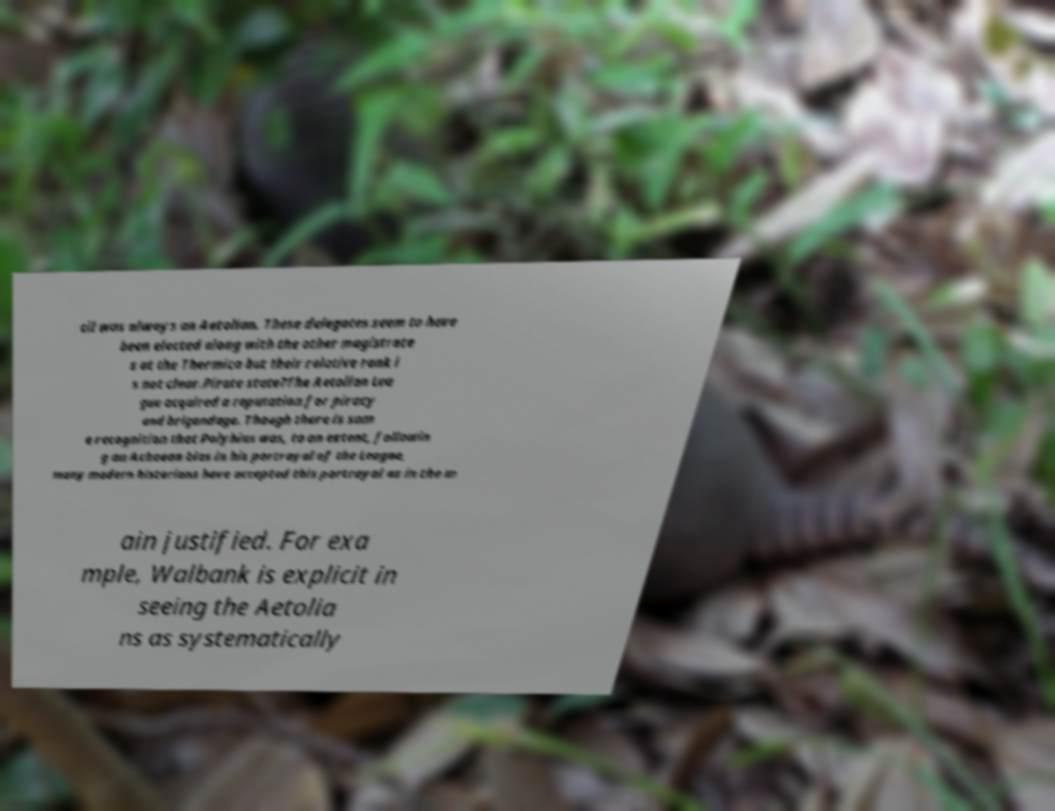There's text embedded in this image that I need extracted. Can you transcribe it verbatim? cil was always an Aetolian. These delegates seem to have been elected along with the other magistrate s at the Thermica but their relative rank i s not clear.Pirate state?The Aetolian Lea gue acquired a reputation for piracy and brigandage. Though there is som e recognition that Polybius was, to an extent, followin g an Achaean bias in his portrayal of the League, many modern historians have accepted this portrayal as in the m ain justified. For exa mple, Walbank is explicit in seeing the Aetolia ns as systematically 